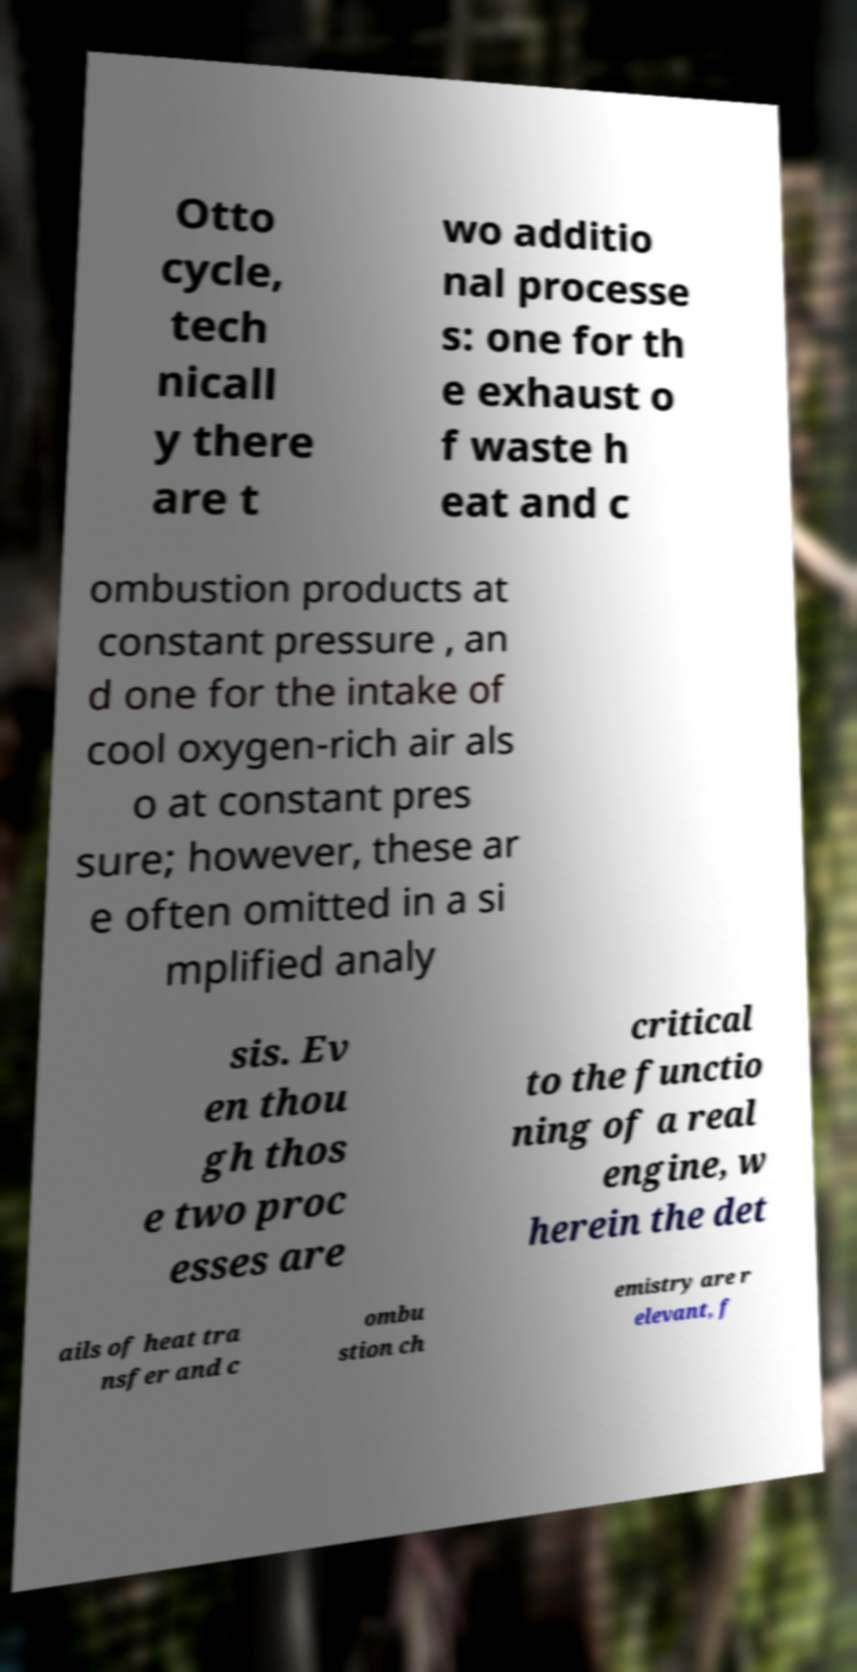What messages or text are displayed in this image? I need them in a readable, typed format. Otto cycle, tech nicall y there are t wo additio nal processe s: one for th e exhaust o f waste h eat and c ombustion products at constant pressure , an d one for the intake of cool oxygen-rich air als o at constant pres sure; however, these ar e often omitted in a si mplified analy sis. Ev en thou gh thos e two proc esses are critical to the functio ning of a real engine, w herein the det ails of heat tra nsfer and c ombu stion ch emistry are r elevant, f 